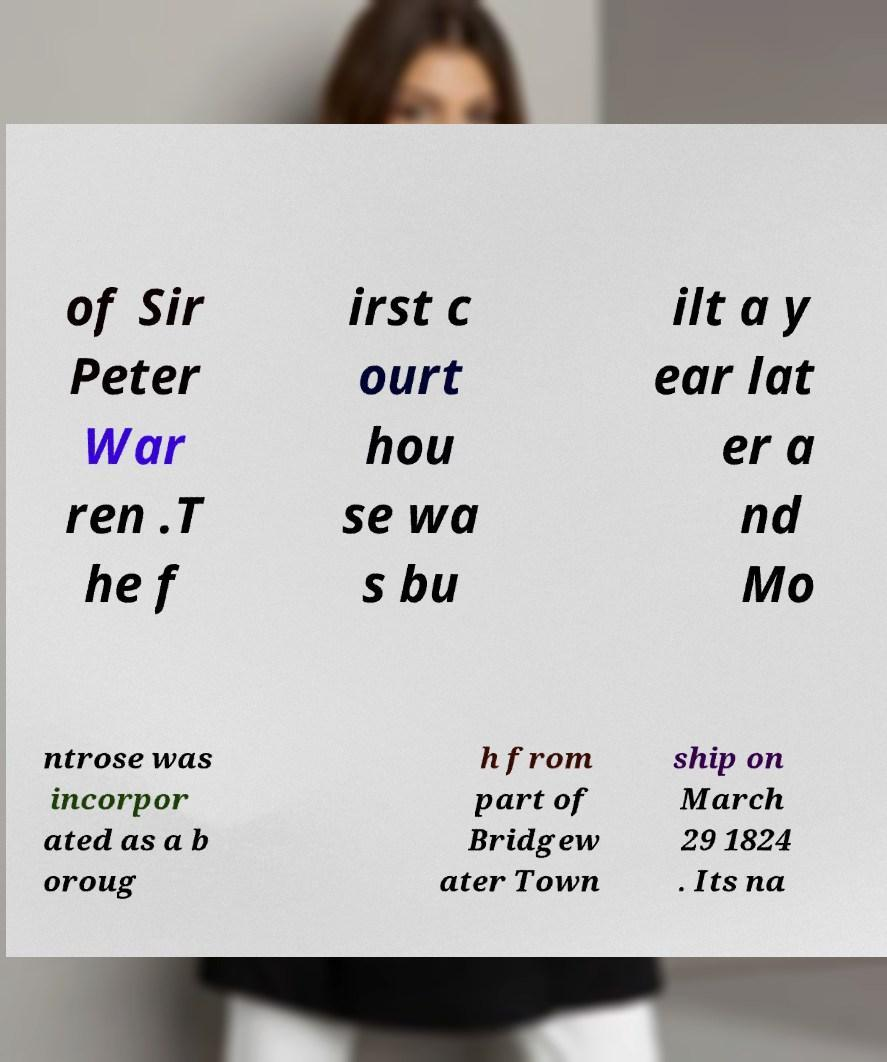There's text embedded in this image that I need extracted. Can you transcribe it verbatim? of Sir Peter War ren .T he f irst c ourt hou se wa s bu ilt a y ear lat er a nd Mo ntrose was incorpor ated as a b oroug h from part of Bridgew ater Town ship on March 29 1824 . Its na 